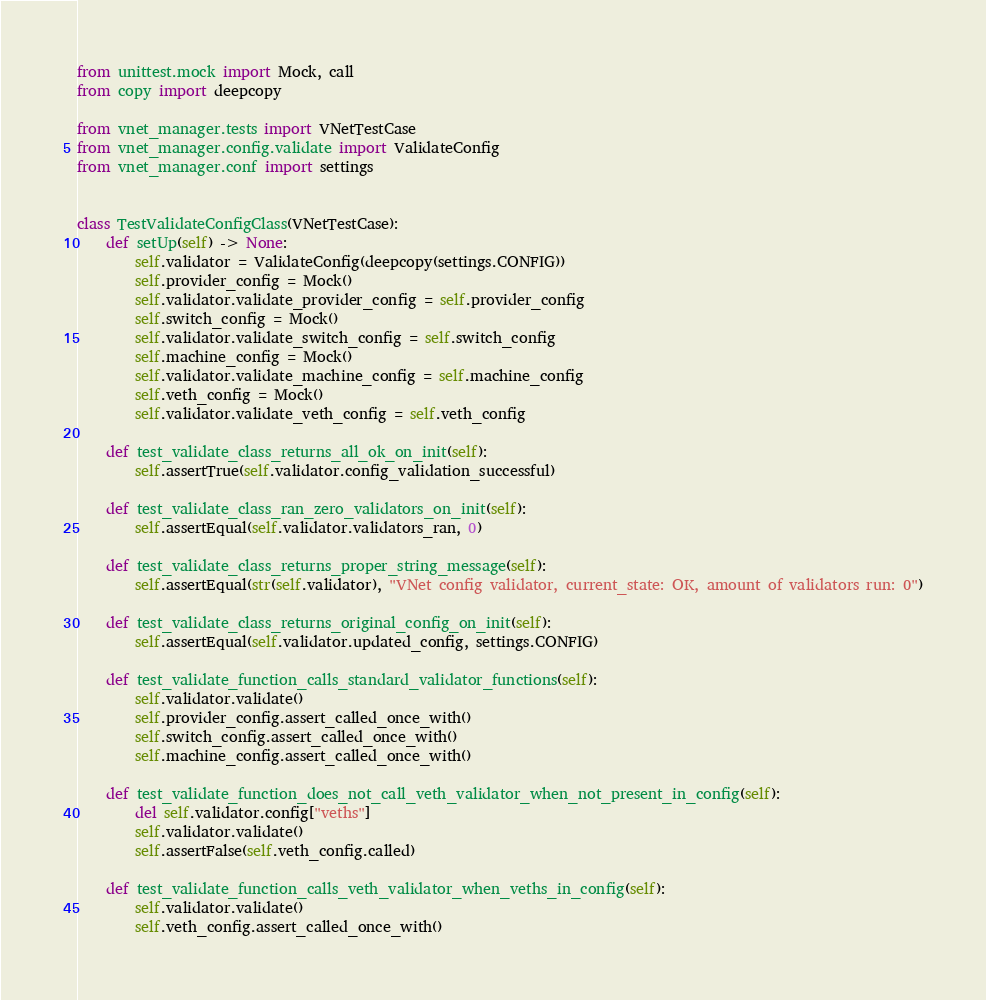<code> <loc_0><loc_0><loc_500><loc_500><_Python_>from unittest.mock import Mock, call
from copy import deepcopy

from vnet_manager.tests import VNetTestCase
from vnet_manager.config.validate import ValidateConfig
from vnet_manager.conf import settings


class TestValidateConfigClass(VNetTestCase):
    def setUp(self) -> None:
        self.validator = ValidateConfig(deepcopy(settings.CONFIG))
        self.provider_config = Mock()
        self.validator.validate_provider_config = self.provider_config
        self.switch_config = Mock()
        self.validator.validate_switch_config = self.switch_config
        self.machine_config = Mock()
        self.validator.validate_machine_config = self.machine_config
        self.veth_config = Mock()
        self.validator.validate_veth_config = self.veth_config

    def test_validate_class_returns_all_ok_on_init(self):
        self.assertTrue(self.validator.config_validation_successful)

    def test_validate_class_ran_zero_validators_on_init(self):
        self.assertEqual(self.validator.validators_ran, 0)

    def test_validate_class_returns_proper_string_message(self):
        self.assertEqual(str(self.validator), "VNet config validator, current_state: OK, amount of validators run: 0")

    def test_validate_class_returns_original_config_on_init(self):
        self.assertEqual(self.validator.updated_config, settings.CONFIG)

    def test_validate_function_calls_standard_validator_functions(self):
        self.validator.validate()
        self.provider_config.assert_called_once_with()
        self.switch_config.assert_called_once_with()
        self.machine_config.assert_called_once_with()

    def test_validate_function_does_not_call_veth_validator_when_not_present_in_config(self):
        del self.validator.config["veths"]
        self.validator.validate()
        self.assertFalse(self.veth_config.called)

    def test_validate_function_calls_veth_validator_when_veths_in_config(self):
        self.validator.validate()
        self.veth_config.assert_called_once_with()

</code> 